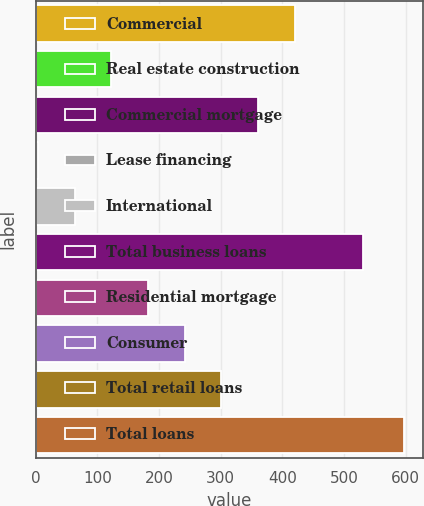<chart> <loc_0><loc_0><loc_500><loc_500><bar_chart><fcel>Commercial<fcel>Real estate construction<fcel>Commercial mortgage<fcel>Lease financing<fcel>International<fcel>Total business loans<fcel>Residential mortgage<fcel>Consumer<fcel>Total retail loans<fcel>Total loans<nl><fcel>419.8<fcel>122.8<fcel>360.4<fcel>4<fcel>63.4<fcel>531<fcel>182.2<fcel>241.6<fcel>301<fcel>598<nl></chart> 